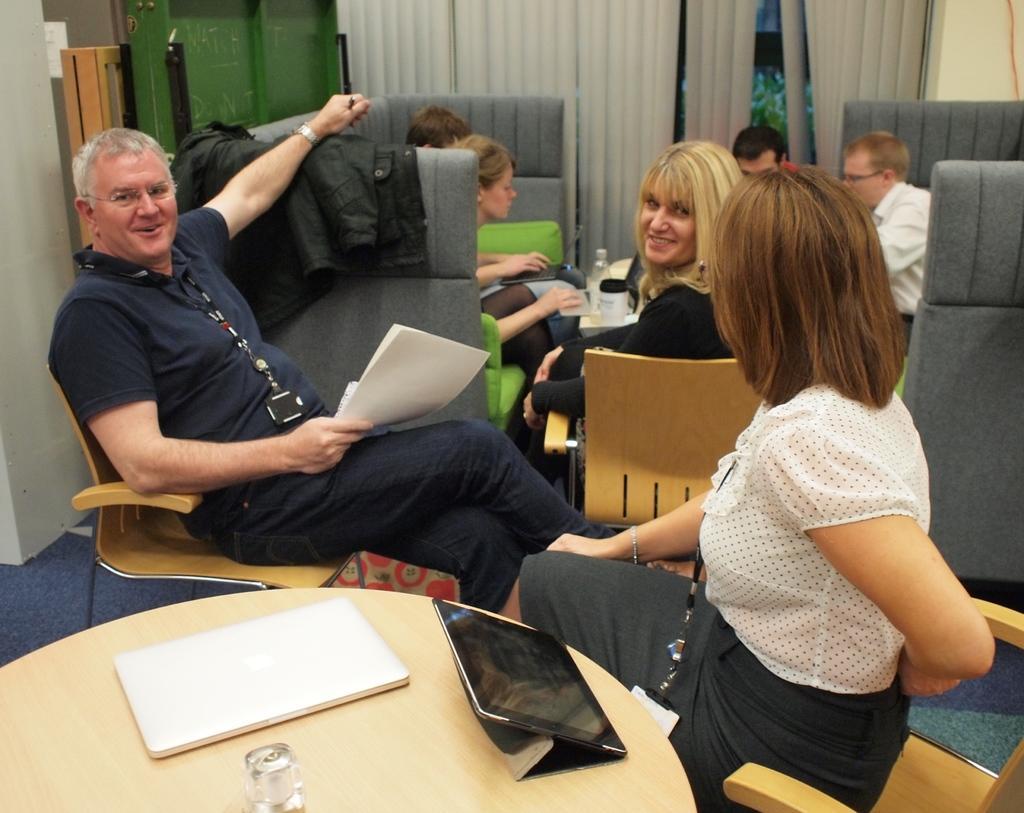Please provide a concise description of this image. In this image there is man , woman sitting in chair and in table there is glass, laptop ,and in back ground there is couch where group of people are sitting , curtain , plants. 